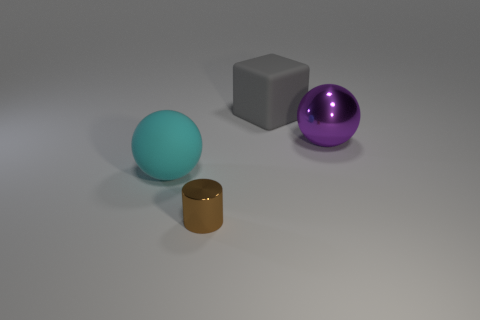What number of tiny brown metal cylinders are behind the brown metal cylinder?
Your answer should be very brief. 0. Are there any gray rubber objects of the same shape as the big shiny object?
Provide a succinct answer. No. There is a big gray matte object; is it the same shape as the brown metallic object that is to the right of the large cyan ball?
Provide a succinct answer. No. What number of balls are matte things or metallic objects?
Offer a very short reply. 2. The object on the left side of the brown shiny object has what shape?
Offer a terse response. Sphere. How many tiny cylinders have the same material as the big purple thing?
Ensure brevity in your answer.  1. Are there fewer purple metallic things that are in front of the cylinder than large cyan rubber balls?
Your answer should be very brief. Yes. What size is the shiny thing that is in front of the large sphere on the right side of the brown metallic cylinder?
Make the answer very short. Small. Do the small object and the sphere that is to the right of the gray rubber block have the same color?
Make the answer very short. No. There is a cyan object that is the same size as the gray block; what material is it?
Keep it short and to the point. Rubber. 